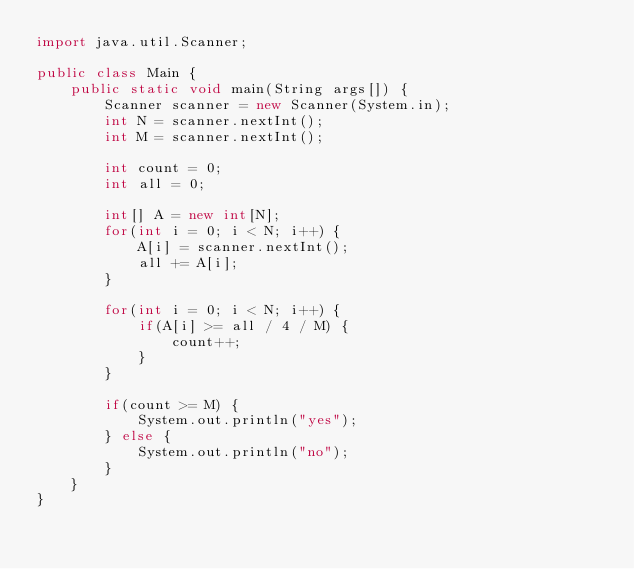Convert code to text. <code><loc_0><loc_0><loc_500><loc_500><_Java_>import java.util.Scanner;

public class Main {
    public static void main(String args[]) {
        Scanner scanner = new Scanner(System.in);
        int N = scanner.nextInt();
        int M = scanner.nextInt();

        int count = 0;
        int all = 0;

        int[] A = new int[N];
        for(int i = 0; i < N; i++) {
            A[i] = scanner.nextInt();
            all += A[i];
        }

        for(int i = 0; i < N; i++) {
            if(A[i] >= all / 4 / M) {
                count++;
            }
        }

        if(count >= M) {
            System.out.println("yes");
        } else {
            System.out.println("no");
        }
    }
}</code> 